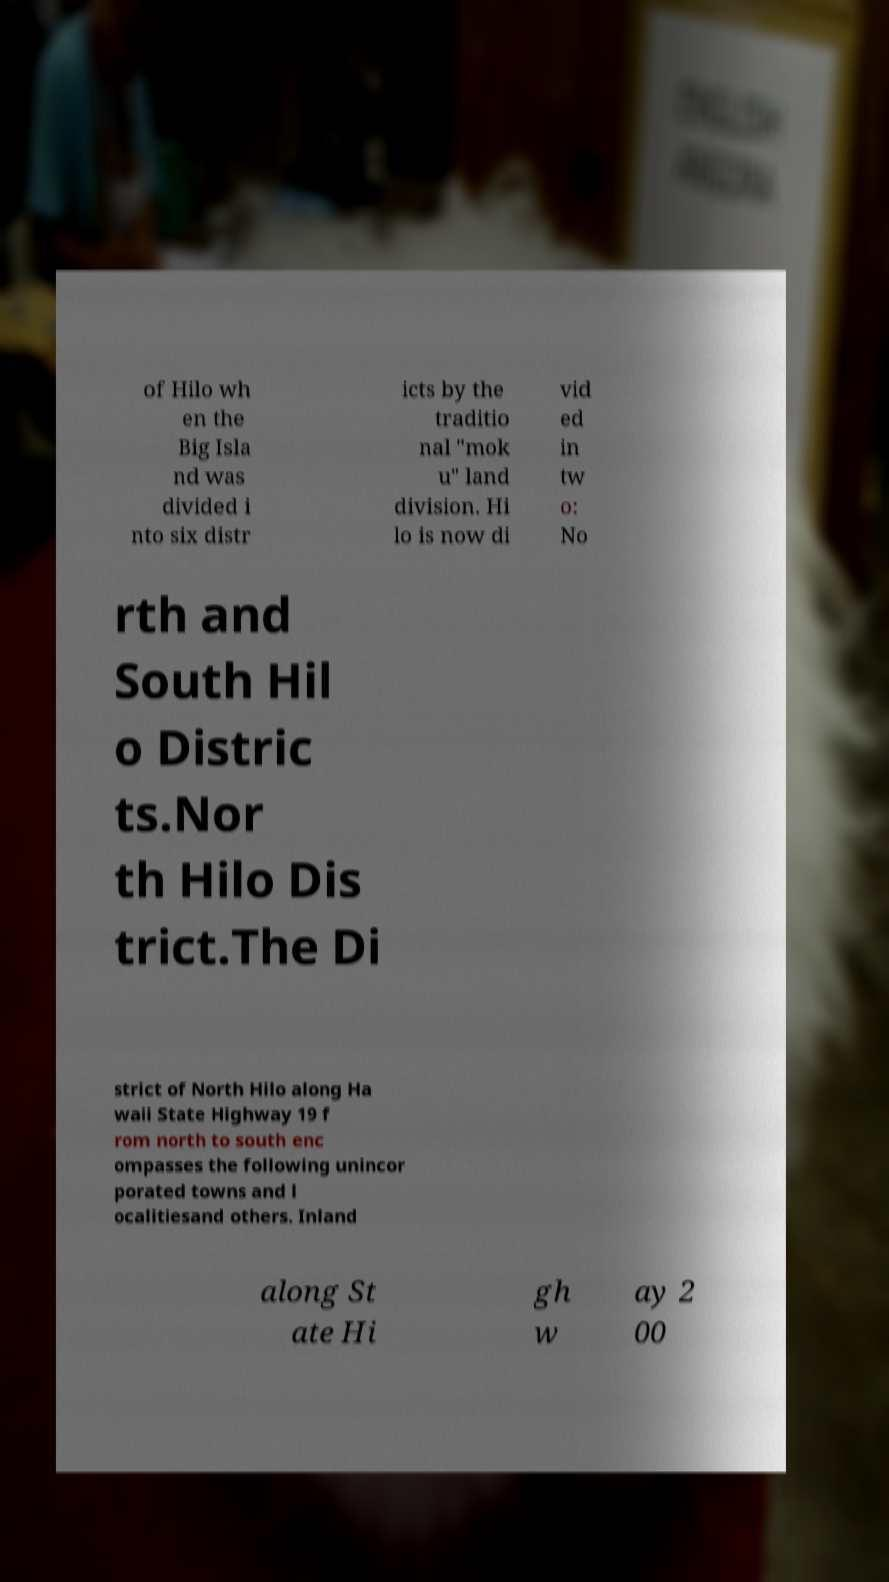Could you assist in decoding the text presented in this image and type it out clearly? of Hilo wh en the Big Isla nd was divided i nto six distr icts by the traditio nal "mok u" land division. Hi lo is now di vid ed in tw o: No rth and South Hil o Distric ts.Nor th Hilo Dis trict.The Di strict of North Hilo along Ha waii State Highway 19 f rom north to south enc ompasses the following unincor porated towns and l ocalitiesand others. Inland along St ate Hi gh w ay 2 00 